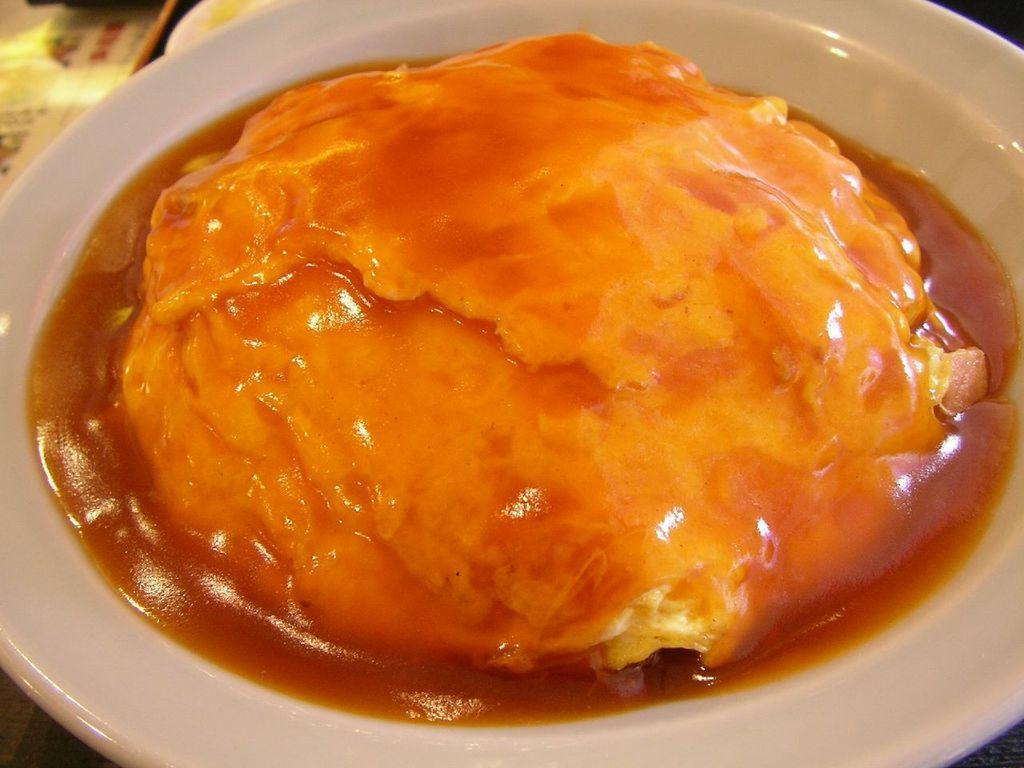Describe this image in one or two sentences. The picture consists of a food item served in a plate. 